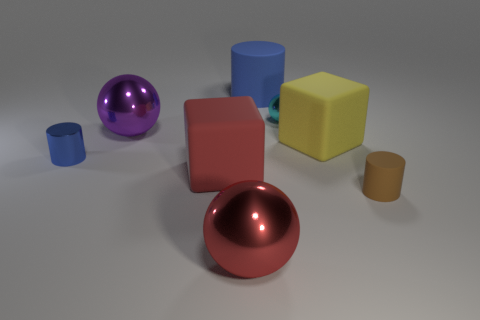What number of balls are either big metal things or purple metal things?
Offer a very short reply. 2. There is a big matte thing that is in front of the yellow thing; what shape is it?
Offer a very short reply. Cube. There is a small cylinder that is to the right of the big red rubber cube that is in front of the rubber cube that is right of the red ball; what color is it?
Provide a succinct answer. Brown. Do the purple thing and the red block have the same material?
Offer a terse response. No. What number of purple objects are tiny metallic things or large objects?
Keep it short and to the point. 1. There is a red matte object; what number of big red rubber blocks are in front of it?
Keep it short and to the point. 0. Are there more big blocks than large gray cylinders?
Your answer should be compact. Yes. There is a small object in front of the red matte object that is on the left side of the large blue rubber cylinder; what shape is it?
Provide a succinct answer. Cylinder. Is the color of the small metallic sphere the same as the large cylinder?
Your answer should be compact. No. Are there more big blue rubber cylinders in front of the big red rubber cube than brown metallic things?
Give a very brief answer. No. 